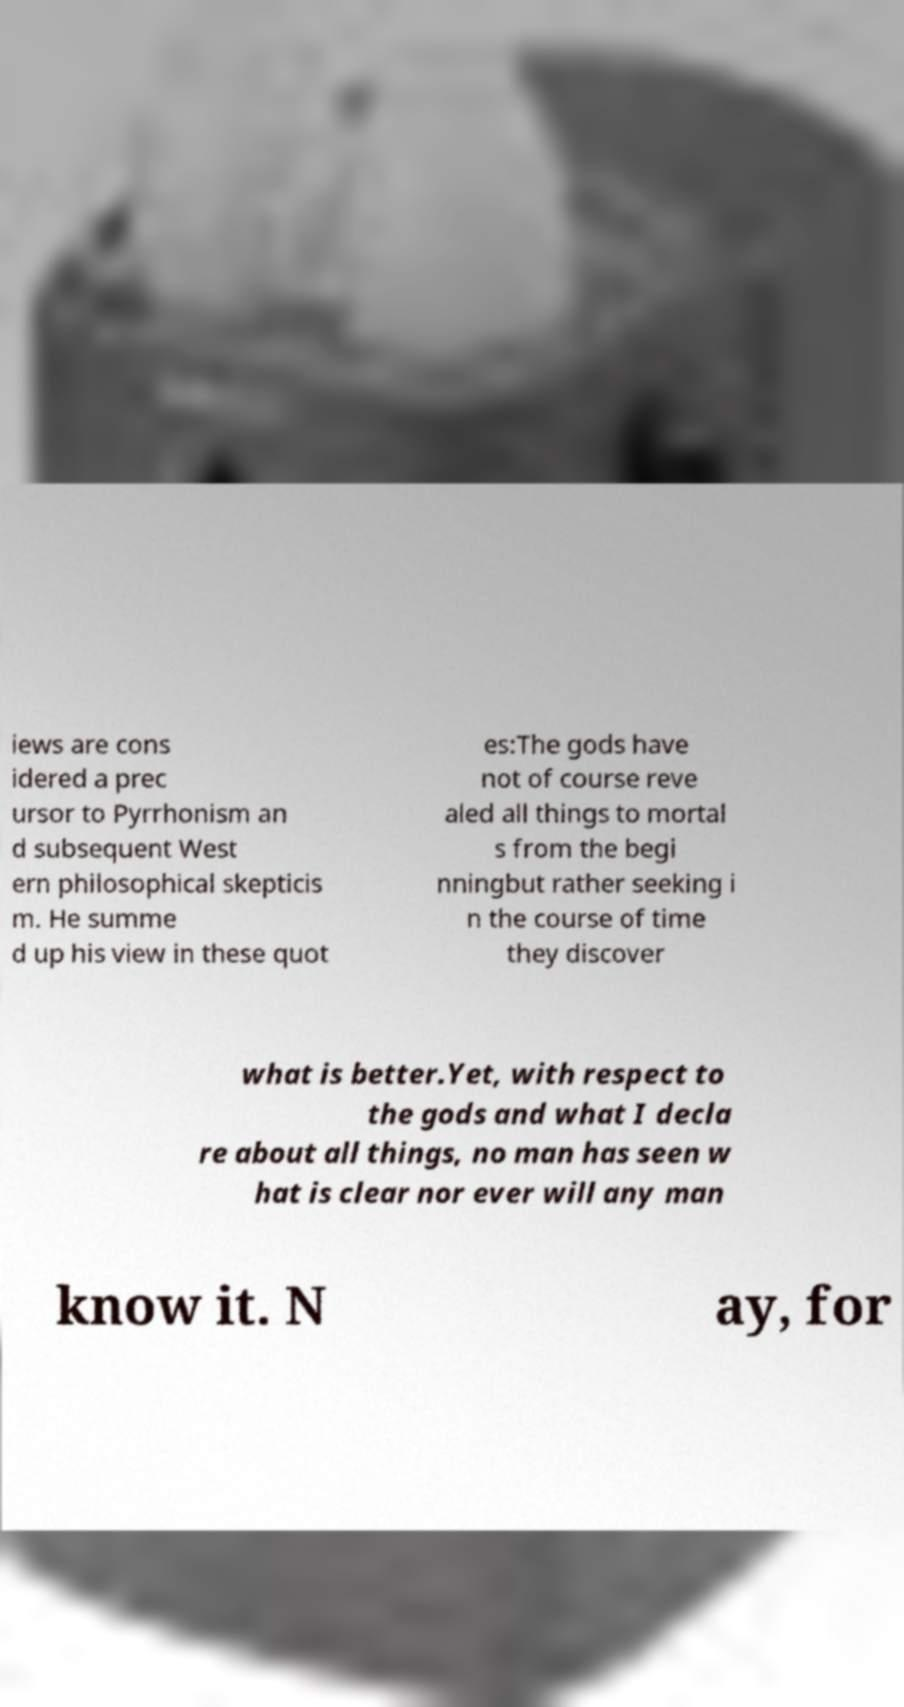Could you assist in decoding the text presented in this image and type it out clearly? iews are cons idered a prec ursor to Pyrrhonism an d subsequent West ern philosophical skepticis m. He summe d up his view in these quot es:The gods have not of course reve aled all things to mortal s from the begi nningbut rather seeking i n the course of time they discover what is better.Yet, with respect to the gods and what I decla re about all things, no man has seen w hat is clear nor ever will any man know it. N ay, for 